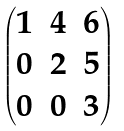<formula> <loc_0><loc_0><loc_500><loc_500>\begin{pmatrix} { 1 } & { 4 } & { 6 } \\ 0 & { 2 } & { 5 } \\ 0 & 0 & { 3 } \\ \end{pmatrix}</formula> 